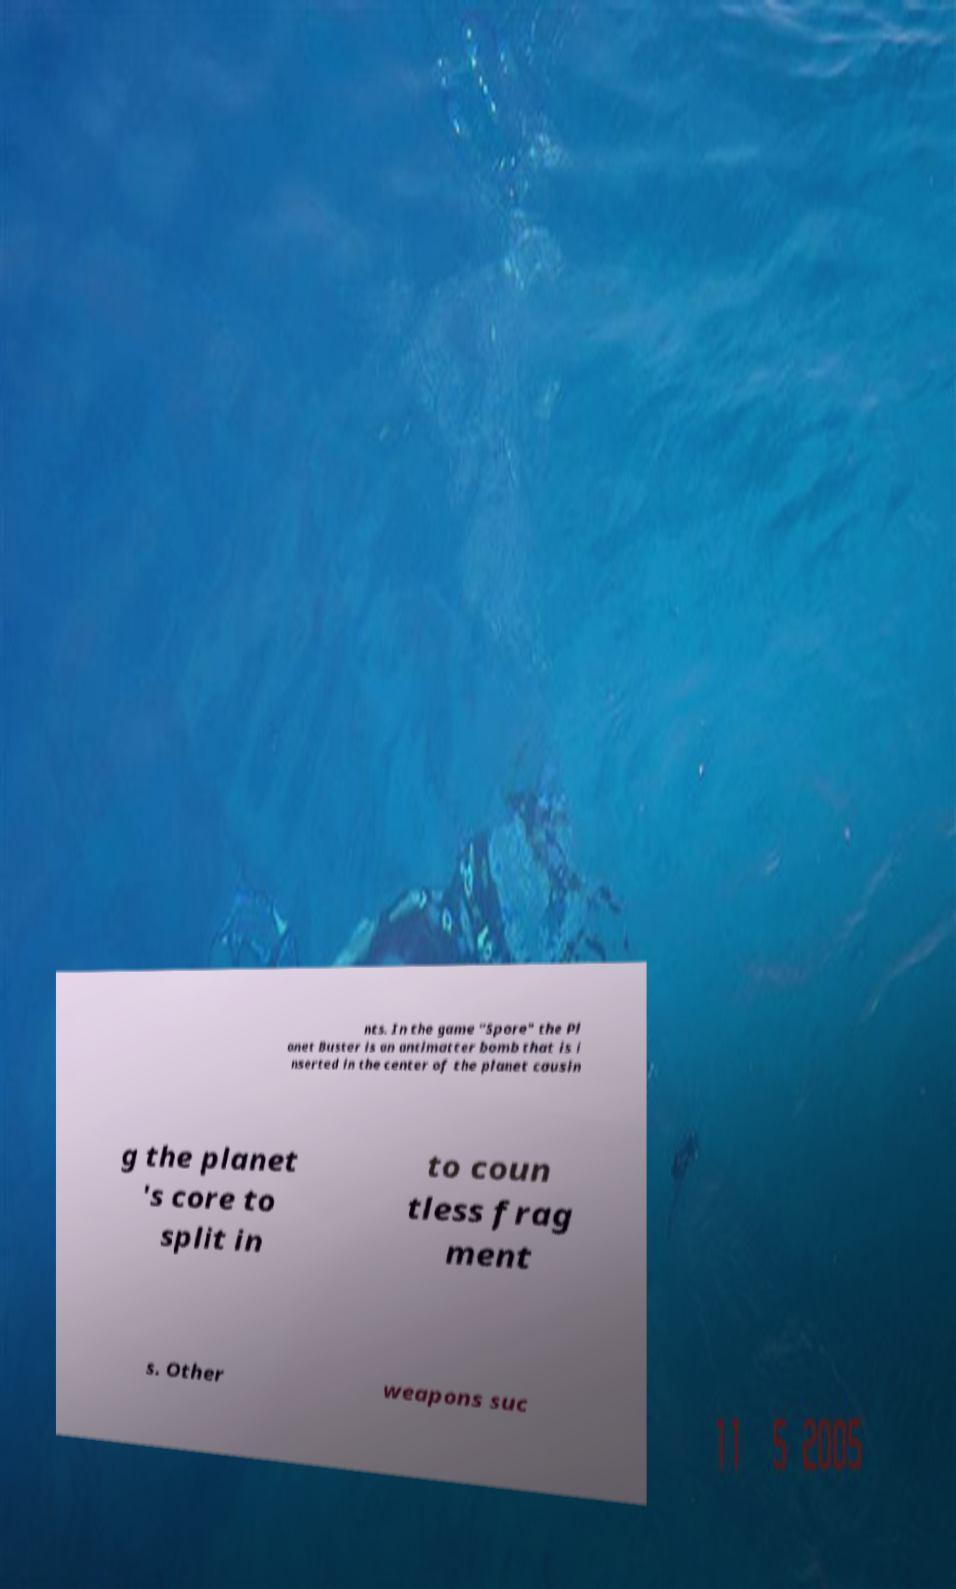Can you accurately transcribe the text from the provided image for me? nts. In the game "Spore" the Pl anet Buster is an antimatter bomb that is i nserted in the center of the planet causin g the planet 's core to split in to coun tless frag ment s. Other weapons suc 